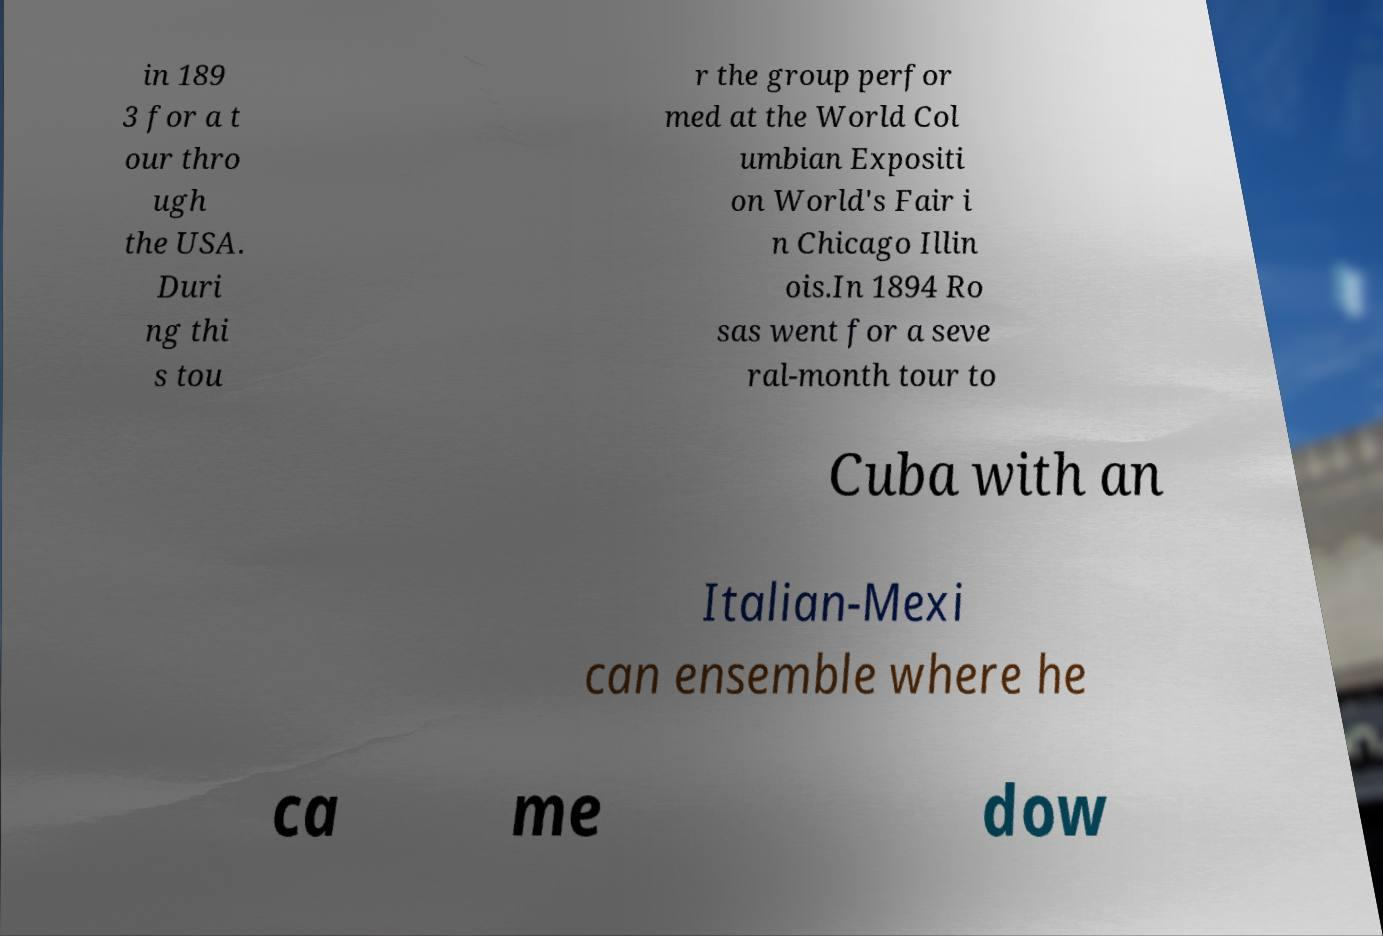Can you accurately transcribe the text from the provided image for me? in 189 3 for a t our thro ugh the USA. Duri ng thi s tou r the group perfor med at the World Col umbian Expositi on World's Fair i n Chicago Illin ois.In 1894 Ro sas went for a seve ral-month tour to Cuba with an Italian-Mexi can ensemble where he ca me dow 